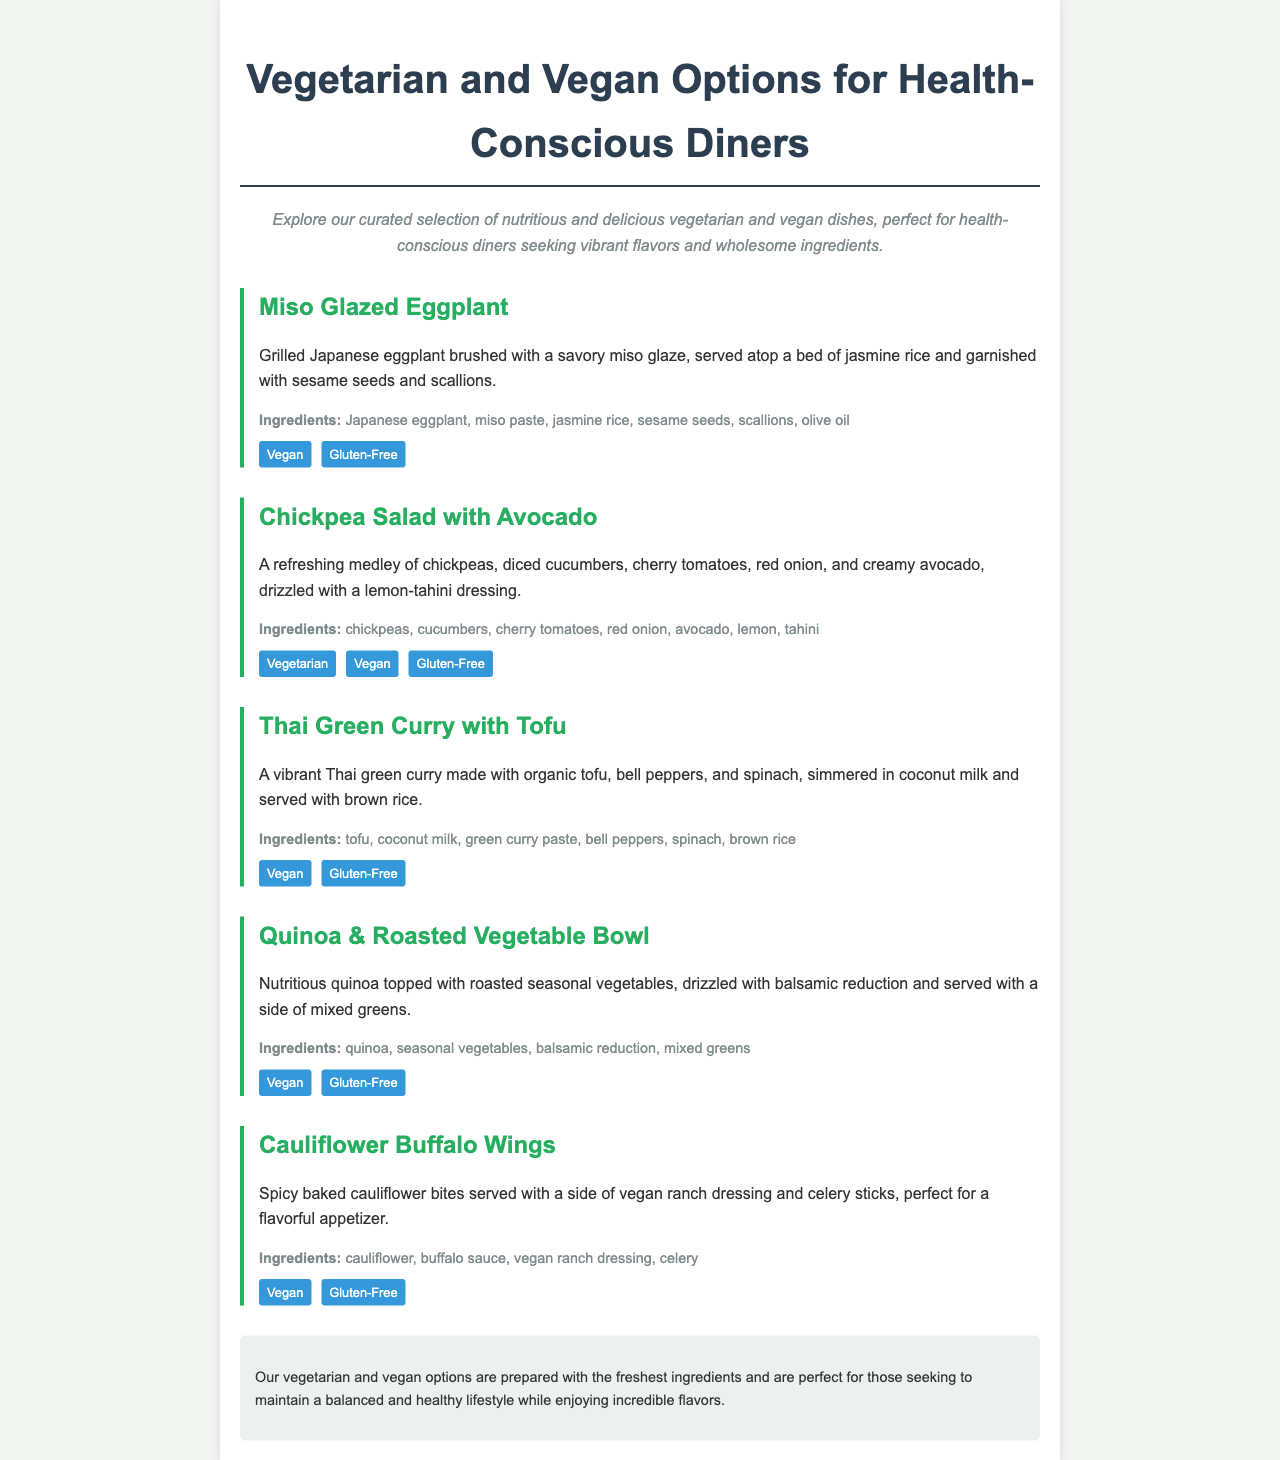What is the title of the menu? The title is prominently displayed at the top of the document, indicating the focus on vegetarian and vegan options.
Answer: Vegetarian and Vegan Options for Health-Conscious Diners How many menu items are listed? Count the individual menu items presented in the document, which are specifically categorized and described.
Answer: Five Which dish contains avocado? The answer can be found by reviewing the ingredients listed under each menu item to identify the presence of avocado.
Answer: Chickpea Salad with Avocado Is the Miso Glazed Eggplant gluten-free? Check the dietary information noted for each menu item to confirm its gluten-free status.
Answer: Yes What is the main ingredient in the Thai Green Curry? By examining the description and ingredient list for the Thai Green Curry, the main ingredient can be identified.
Answer: Tofu What type of dressing is served with the Cauliflower Buffalo Wings? The dressing is specifically mentioned in relation to the Cauliflower Buffalo Wings as a side item for the dish.
Answer: Vegan ranch dressing How is the Quinoa & Roasted Vegetable Bowl served? The description of the bowl clarifies how it is presented to diners, including any accompaniments.
Answer: With a side of mixed greens What flavor profile is highlighted in the Miso Glazed Eggplant? The description references a specific flavor that characterizes the dish, giving insight into its taste experience.
Answer: Savory 